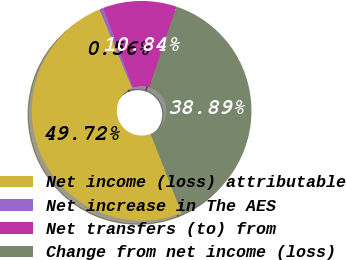Convert chart. <chart><loc_0><loc_0><loc_500><loc_500><pie_chart><fcel>Net income (loss) attributable<fcel>Net increase in The AES<fcel>Net transfers (to) from<fcel>Change from net income (loss)<nl><fcel>49.72%<fcel>0.56%<fcel>10.84%<fcel>38.89%<nl></chart> 